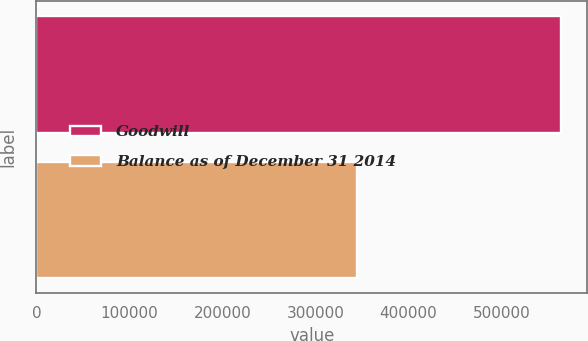Convert chart to OTSL. <chart><loc_0><loc_0><loc_500><loc_500><bar_chart><fcel>Goodwill<fcel>Balance as of December 31 2014<nl><fcel>564089<fcel>344650<nl></chart> 